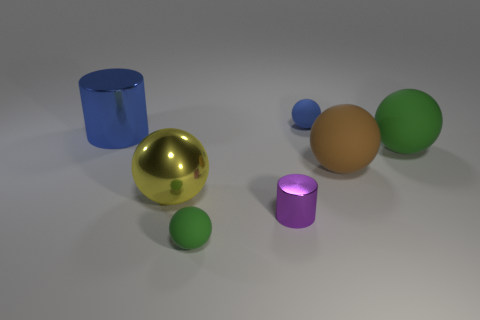Subtract all blue balls. How many balls are left? 4 Subtract all gray spheres. Subtract all yellow cylinders. How many spheres are left? 5 Add 3 metal objects. How many objects exist? 10 Subtract all spheres. How many objects are left? 2 Subtract all balls. Subtract all large metal cylinders. How many objects are left? 1 Add 3 blue balls. How many blue balls are left? 4 Add 6 big green rubber spheres. How many big green rubber spheres exist? 7 Subtract 0 purple cubes. How many objects are left? 7 